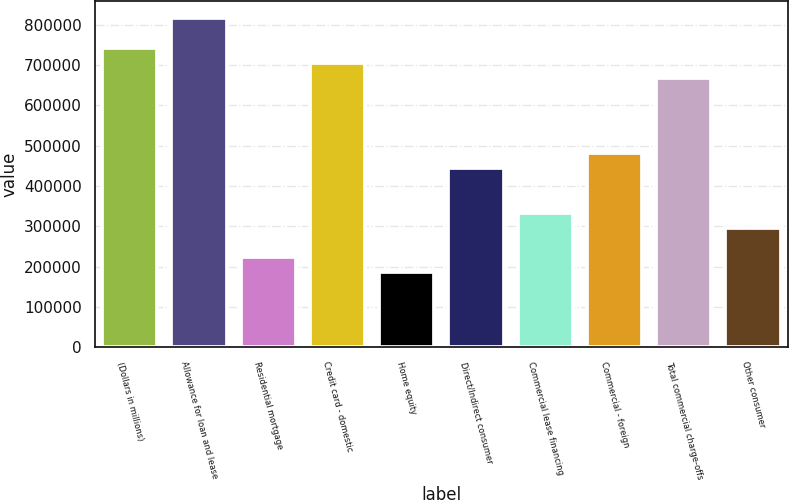<chart> <loc_0><loc_0><loc_500><loc_500><bar_chart><fcel>(Dollars in millions)<fcel>Allowance for loan and lease<fcel>Residential mortgage<fcel>Credit card - domestic<fcel>Home equity<fcel>Direct/Indirect consumer<fcel>Commercial lease financing<fcel>Commercial - foreign<fcel>Total commercial charge-offs<fcel>Other consumer<nl><fcel>742865<fcel>817151<fcel>222860<fcel>705722<fcel>185717<fcel>445719<fcel>334290<fcel>482863<fcel>668579<fcel>297147<nl></chart> 